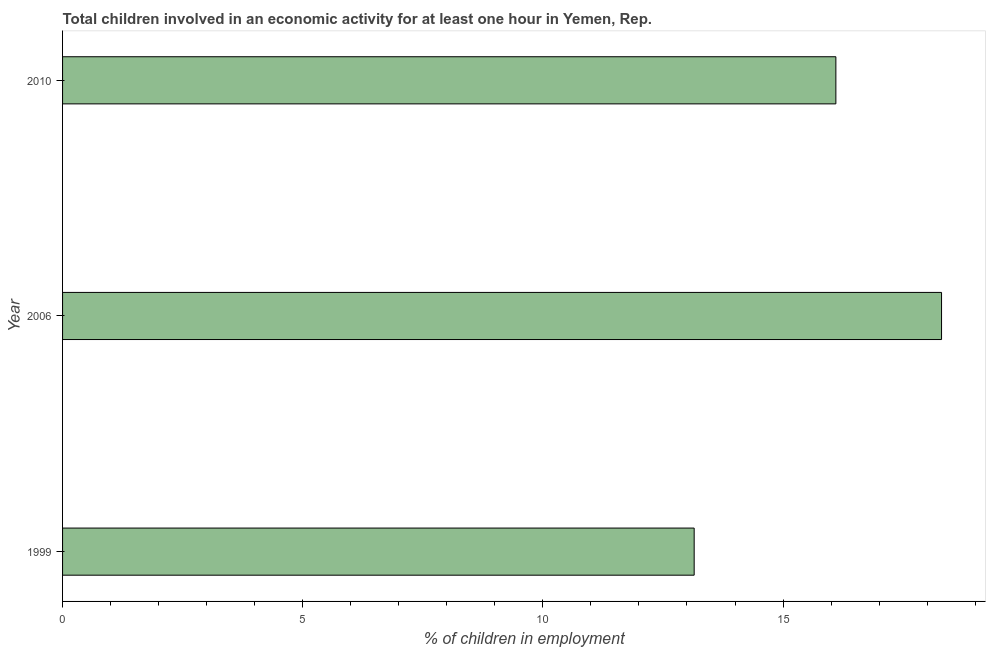Does the graph contain any zero values?
Provide a short and direct response. No. Does the graph contain grids?
Offer a very short reply. No. What is the title of the graph?
Offer a terse response. Total children involved in an economic activity for at least one hour in Yemen, Rep. What is the label or title of the X-axis?
Provide a succinct answer. % of children in employment. Across all years, what is the maximum percentage of children in employment?
Offer a very short reply. 18.3. Across all years, what is the minimum percentage of children in employment?
Provide a succinct answer. 13.15. What is the sum of the percentage of children in employment?
Keep it short and to the point. 47.55. What is the difference between the percentage of children in employment in 1999 and 2006?
Your answer should be compact. -5.15. What is the average percentage of children in employment per year?
Your answer should be compact. 15.85. In how many years, is the percentage of children in employment greater than 6 %?
Your answer should be compact. 3. Do a majority of the years between 1999 and 2010 (inclusive) have percentage of children in employment greater than 14 %?
Your answer should be very brief. Yes. What is the ratio of the percentage of children in employment in 2006 to that in 2010?
Provide a succinct answer. 1.14. Is the difference between the percentage of children in employment in 1999 and 2010 greater than the difference between any two years?
Ensure brevity in your answer.  No. What is the difference between the highest and the second highest percentage of children in employment?
Provide a succinct answer. 2.2. What is the difference between the highest and the lowest percentage of children in employment?
Provide a short and direct response. 5.15. In how many years, is the percentage of children in employment greater than the average percentage of children in employment taken over all years?
Keep it short and to the point. 2. How many bars are there?
Keep it short and to the point. 3. What is the difference between two consecutive major ticks on the X-axis?
Offer a very short reply. 5. Are the values on the major ticks of X-axis written in scientific E-notation?
Ensure brevity in your answer.  No. What is the % of children in employment in 1999?
Your response must be concise. 13.15. What is the % of children in employment in 2006?
Offer a very short reply. 18.3. What is the % of children in employment of 2010?
Ensure brevity in your answer.  16.1. What is the difference between the % of children in employment in 1999 and 2006?
Your response must be concise. -5.15. What is the difference between the % of children in employment in 1999 and 2010?
Provide a succinct answer. -2.95. What is the difference between the % of children in employment in 2006 and 2010?
Make the answer very short. 2.2. What is the ratio of the % of children in employment in 1999 to that in 2006?
Offer a terse response. 0.72. What is the ratio of the % of children in employment in 1999 to that in 2010?
Your answer should be compact. 0.82. What is the ratio of the % of children in employment in 2006 to that in 2010?
Provide a short and direct response. 1.14. 